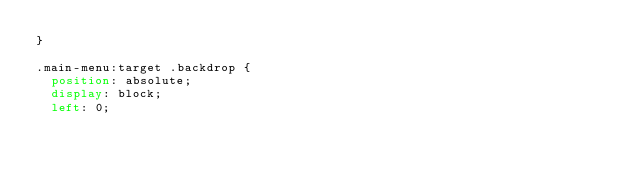<code> <loc_0><loc_0><loc_500><loc_500><_CSS_>}

.main-menu:target .backdrop {
  position: absolute;
  display: block;  
  left: 0;</code> 